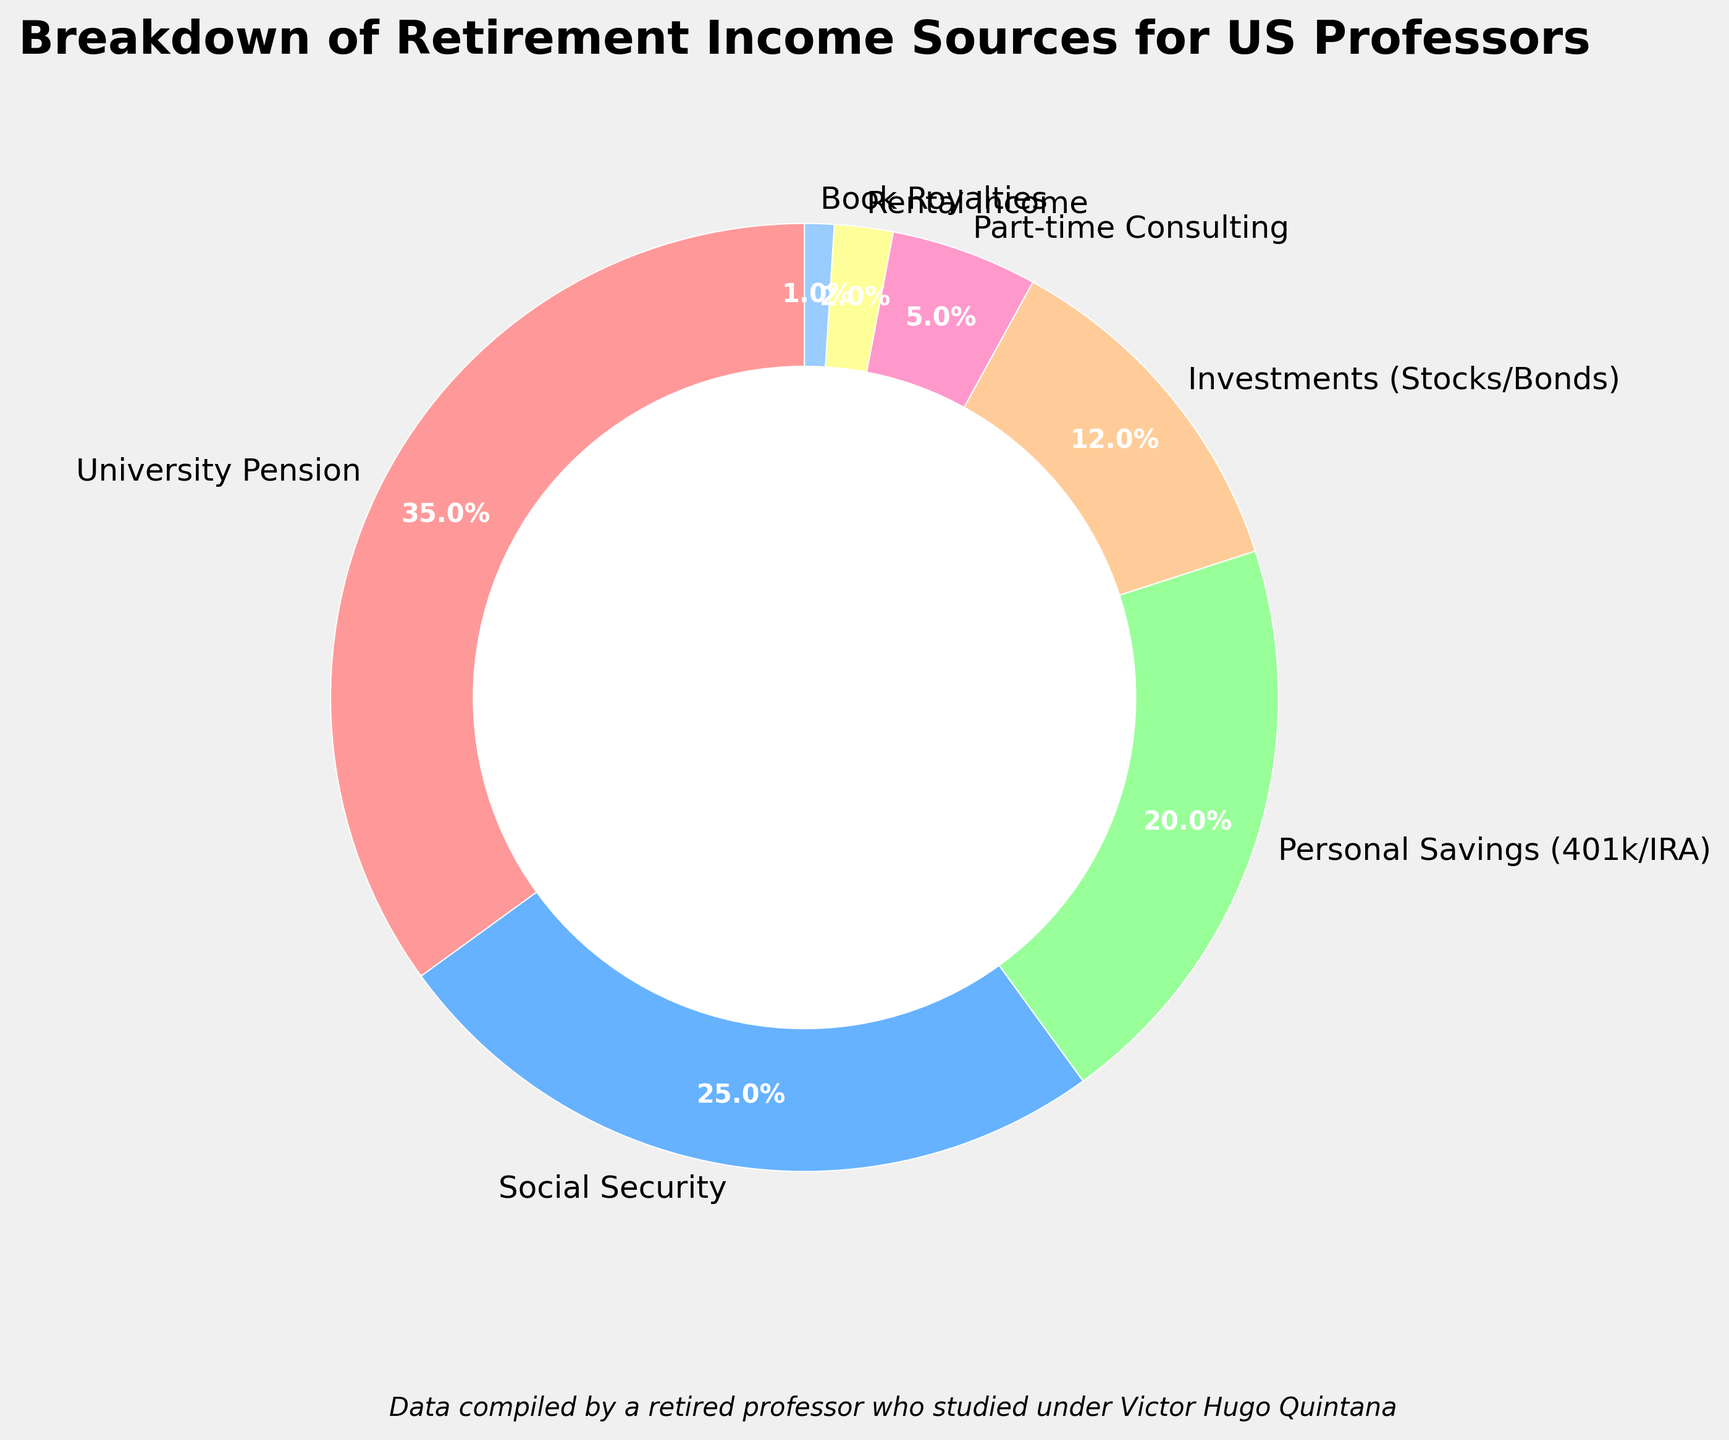Which income source contributes the largest percentage to the retirement income of US professors? The largest segment in the pie chart can be identified by visual inspection since it occupies the most space. "University Pension" is the largest segment with a percentage of 35%.
Answer: University Pension Which income source has the smallest contribution to the retirement income of US professors? The smallest segment in the pie chart occupies the least space. "Book Royalties" is the smallest with a percentage of 1%.
Answer: Book Royalties How does the combined percentage of Social Security and Personal Savings compare to the percentage contributed by University Pension? The combined percentage of Social Security (25%) and Personal Savings (20%) is 45%. University Pension contributes 35%. Therefore, the combined percentage (45%) is greater than the University Pension percentage (35%).
Answer: Combined percentage is greater What is the difference in percentage between Investments and Part-time Consulting as retirement income sources? Investments contribute 12% and Part-time Consulting contributes 5%. The difference can be calculated as 12% - 5% = 7%.
Answer: 7% Is the percentage of Part-time Consulting and Rental Income combined greater than Personal Savings? Part-time Consulting is 5% and Rental Income is 2%. Their combined contribution is 5% + 2% = 7%. Personal Savings contribute 20%, which is greater than the combined 7%.
Answer: Combined percentage is less What percentage of retirement income comes from the combination of University Pension and Social Security? University Pension contributes 35% and Social Security contributes 25%. Their combined contribution is 35% + 25% = 60%.
Answer: 60% How do the contributions of Personal Savings and Investments compare in percentage terms? Personal Savings contribute 20% and Investments contribute 12%. By visual inspection, Personal Savings have a larger percentage than Investments.
Answer: Personal Savings have a larger percentage Does the combined contribution of Rental Income and Book Royalties exceed the contribution of Part-time Consulting? Rental Income contributes 2% and Book Royalties contribute 1%. Their combined contribution is 2% + 1% = 3%. Part-time Consulting contributes 5%, which is greater than the combined 3%.
Answer: Combined contribution is less 